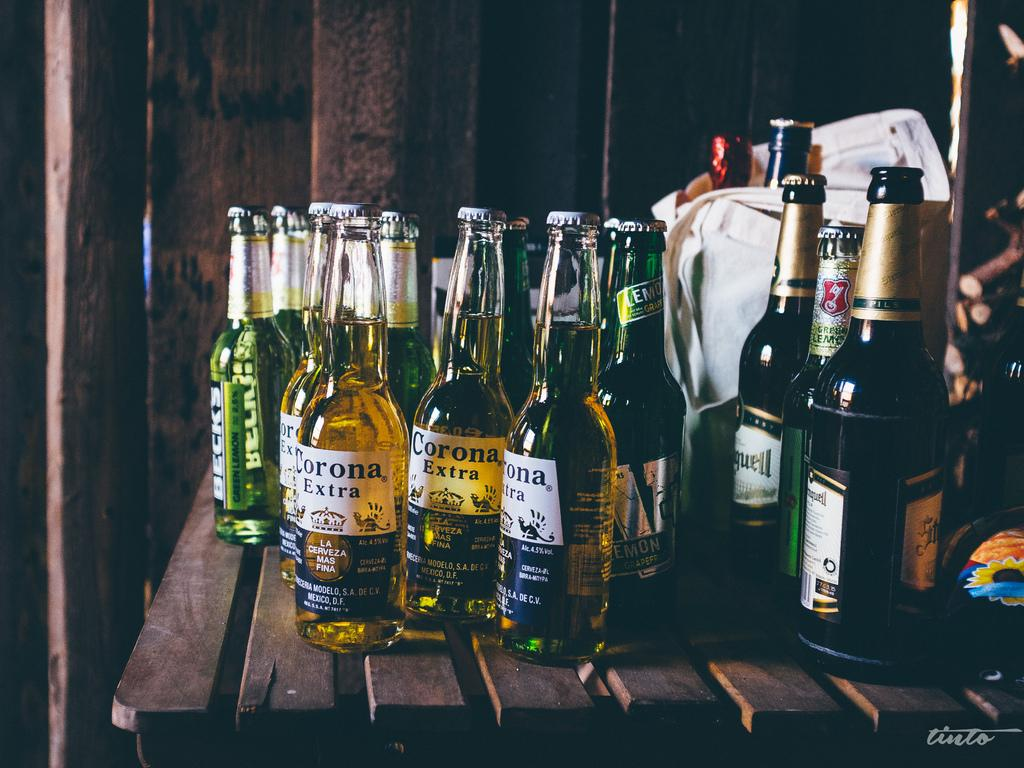Provide a one-sentence caption for the provided image. several bottles of Corona Extra beer on a wooden table. 